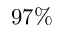<formula> <loc_0><loc_0><loc_500><loc_500>9 7 \%</formula> 